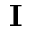Convert formula to latex. <formula><loc_0><loc_0><loc_500><loc_500>{ I }</formula> 